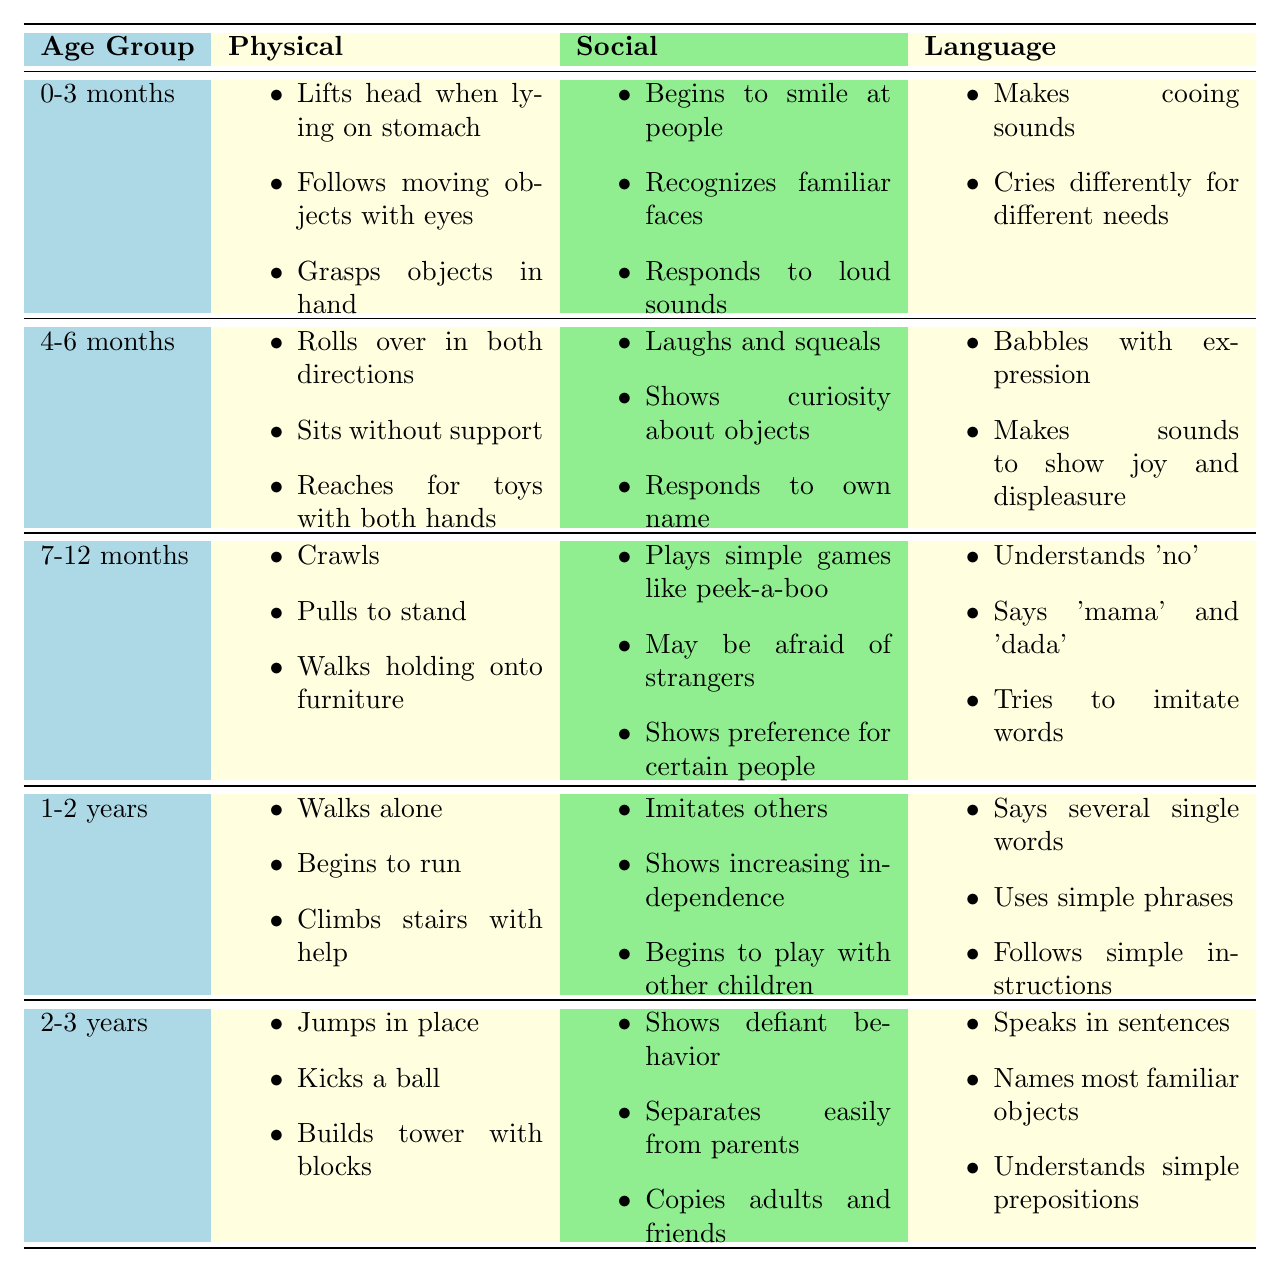What are the physical milestones for children aged 4-6 months? The table lists the physical milestones for the 4-6 months age group as follows: Rolls over in both directions, sits without support, and reaches for toys with both hands.
Answer: Rolls over in both directions, sits without support, reaches for toys with both hands What social skills do children develop between 0-3 months? According to the table, children aged 0-3 months show social skills such as beginning to smile at people, recognizing familiar faces, and responding to loud sounds.
Answer: Begins to smile at people, recognizes familiar faces, responds to loud sounds How many physical milestones are listed for the 1-2 years age group? The table shows three physical milestones listed for the 1-2 years age group: walks alone, begins to run, climbs stairs with help. Thus, there are 3 milestones in total.
Answer: 3 Is it true that children aged 2-3 years jump in place? The table indicates that one of the milestones for children aged 2-3 years is jumping in place, therefore the statement is true.
Answer: Yes Which age group has the most language milestones listed? To find this, we compare the language milestones: 0-3 months has 2, 4-6 months has 2, 7-12 months has 3, 1-2 years has 3, and 2-3 years has 3. The 7-12 months, 1-2 years, and 2-3 years groups tie for the most with 3 milestones each.
Answer: 7-12 months, 1-2 years, 2-3 years (3 milestones each) What do children aged 1-2 years start to say? The table details that children aged 1-2 years start to say several single words, use simple phrases, and follow simple instructions.
Answer: Several single words, simple phrases, simple instructions 